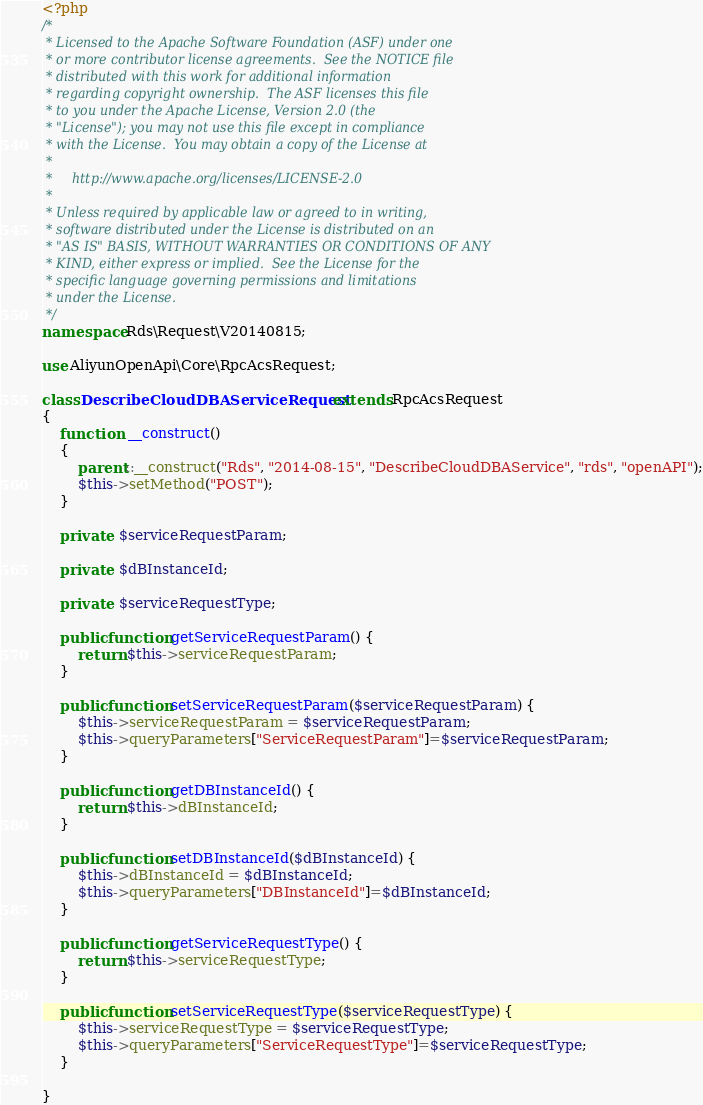<code> <loc_0><loc_0><loc_500><loc_500><_PHP_><?php
/*
 * Licensed to the Apache Software Foundation (ASF) under one
 * or more contributor license agreements.  See the NOTICE file
 * distributed with this work for additional information
 * regarding copyright ownership.  The ASF licenses this file
 * to you under the Apache License, Version 2.0 (the
 * "License"); you may not use this file except in compliance
 * with the License.  You may obtain a copy of the License at
 *
 *     http://www.apache.org/licenses/LICENSE-2.0
 *
 * Unless required by applicable law or agreed to in writing,
 * software distributed under the License is distributed on an
 * "AS IS" BASIS, WITHOUT WARRANTIES OR CONDITIONS OF ANY
 * KIND, either express or implied.  See the License for the
 * specific language governing permissions and limitations
 * under the License.
 */
namespace Rds\Request\V20140815;

use AliyunOpenApi\Core\RpcAcsRequest;

class DescribeCloudDBAServiceRequest extends RpcAcsRequest
{
	function  __construct()
	{
		parent::__construct("Rds", "2014-08-15", "DescribeCloudDBAService", "rds", "openAPI");
		$this->setMethod("POST");
	}

	private  $serviceRequestParam;

	private  $dBInstanceId;

	private  $serviceRequestType;

	public function getServiceRequestParam() {
		return $this->serviceRequestParam;
	}

	public function setServiceRequestParam($serviceRequestParam) {
		$this->serviceRequestParam = $serviceRequestParam;
		$this->queryParameters["ServiceRequestParam"]=$serviceRequestParam;
	}

	public function getDBInstanceId() {
		return $this->dBInstanceId;
	}

	public function setDBInstanceId($dBInstanceId) {
		$this->dBInstanceId = $dBInstanceId;
		$this->queryParameters["DBInstanceId"]=$dBInstanceId;
	}

	public function getServiceRequestType() {
		return $this->serviceRequestType;
	}

	public function setServiceRequestType($serviceRequestType) {
		$this->serviceRequestType = $serviceRequestType;
		$this->queryParameters["ServiceRequestType"]=$serviceRequestType;
	}
	
}</code> 